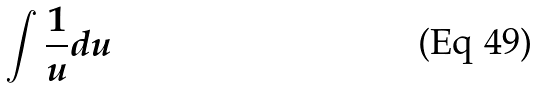<formula> <loc_0><loc_0><loc_500><loc_500>\int \frac { 1 } { u } d u</formula> 